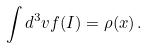Convert formula to latex. <formula><loc_0><loc_0><loc_500><loc_500>\int d ^ { 3 } { v } f ( { I } ) = \rho ( { x } ) \, .</formula> 